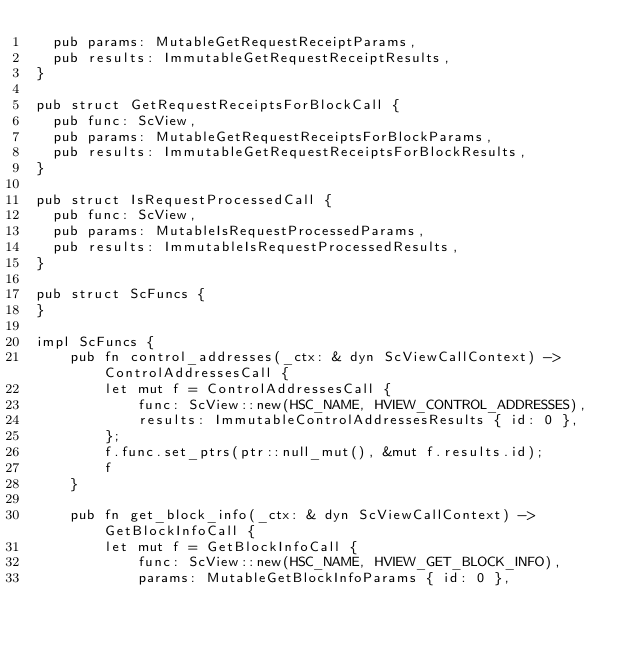<code> <loc_0><loc_0><loc_500><loc_500><_Rust_>	pub params: MutableGetRequestReceiptParams,
	pub results: ImmutableGetRequestReceiptResults,
}

pub struct GetRequestReceiptsForBlockCall {
	pub func: ScView,
	pub params: MutableGetRequestReceiptsForBlockParams,
	pub results: ImmutableGetRequestReceiptsForBlockResults,
}

pub struct IsRequestProcessedCall {
	pub func: ScView,
	pub params: MutableIsRequestProcessedParams,
	pub results: ImmutableIsRequestProcessedResults,
}

pub struct ScFuncs {
}

impl ScFuncs {
    pub fn control_addresses(_ctx: & dyn ScViewCallContext) -> ControlAddressesCall {
        let mut f = ControlAddressesCall {
            func: ScView::new(HSC_NAME, HVIEW_CONTROL_ADDRESSES),
            results: ImmutableControlAddressesResults { id: 0 },
        };
        f.func.set_ptrs(ptr::null_mut(), &mut f.results.id);
        f
    }

    pub fn get_block_info(_ctx: & dyn ScViewCallContext) -> GetBlockInfoCall {
        let mut f = GetBlockInfoCall {
            func: ScView::new(HSC_NAME, HVIEW_GET_BLOCK_INFO),
            params: MutableGetBlockInfoParams { id: 0 },</code> 